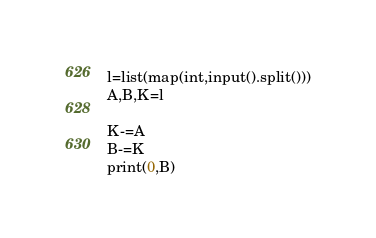Convert code to text. <code><loc_0><loc_0><loc_500><loc_500><_Python_>l=list(map(int,input().split()))
A,B,K=l

K-=A
B-=K
print(0,B)

</code> 